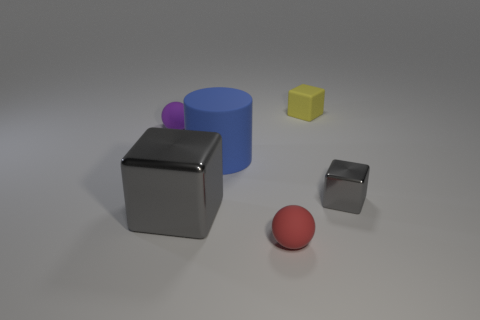There is a large gray shiny thing; what shape is it?
Give a very brief answer. Cube. There is a tiny block that is made of the same material as the large gray thing; what color is it?
Give a very brief answer. Gray. Is the number of tiny rubber cubes greater than the number of big gray rubber spheres?
Ensure brevity in your answer.  Yes. Are there any tiny purple matte things?
Provide a short and direct response. Yes. There is a big blue matte thing that is behind the metal cube that is behind the big block; what shape is it?
Make the answer very short. Cylinder. What number of things are either gray cubes or tiny rubber blocks that are on the right side of the blue cylinder?
Offer a very short reply. 3. What is the color of the small rubber thing that is to the left of the small rubber sphere in front of the matte sphere behind the blue object?
Keep it short and to the point. Purple. There is another tiny thing that is the same shape as the yellow thing; what is it made of?
Ensure brevity in your answer.  Metal. The matte cube has what color?
Your response must be concise. Yellow. Is the color of the big rubber cylinder the same as the small metal block?
Offer a terse response. No. 